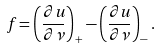<formula> <loc_0><loc_0><loc_500><loc_500>f = \left ( \frac { \partial u } { \partial \nu } \right ) _ { + } - \left ( \frac { \partial u } { \partial \nu } \right ) _ { - } .</formula> 